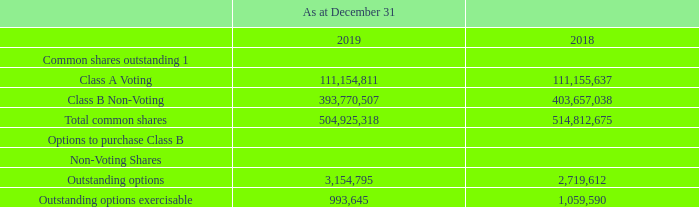OUTSTANDING COMMON SHARES
1 Holders of our Class B Non-Voting Shares are entitled to receive notice of and to attend shareholder meetings; however, they are not entitled to vote at these meetings except as required by law or stipulated by stock exchanges. If an offer is made to purchase outstanding Class A Shares, there is no requirement under applicable law or our constating documents that an offer be made for the outstanding Class B Non-Voting Shares, and there is no other protection available to shareholders under our constating documents. If an offer is made to purchase both classes of shares, the offer for the Class A Shares may be made on different terms than the offer to the holders of Class B Non-Voting Shares.
As at February 29, 2020, 111,154,811 Class A Shares, 393,770,507
Class B Non-Voting Shares, and 3,145,274 options to purchase
Class B Non-Voting Shares were outstanding.
What were the number of Class A shares outstanding as at February 29, 2020? 111,154,811. What were the number of Class B shares outstanding as at February 29, 2020? 393,770,507. How are the terms of purchase structured in case both the classes of shares are to be purchased? If an offer is made to purchase both classes of shares, the offer for the class a shares may be made on different terms than the offer to the holders of class b non-voting shares. What is the increase / (decrease) in the Class A Voting shares from 2018 to 2019? 111,154,811 - 111,155,637
Answer: -826. What is the average Class B Non-Voting shares? (393,770,507 + 403,657,038) / 2
Answer: 398713772.5. What was the percentage increase / (decrease) in Total common shares from 2018 to 2019?
Answer scale should be: percent. 504,925,318 / 514,812,675 - 1
Answer: -1.92. 